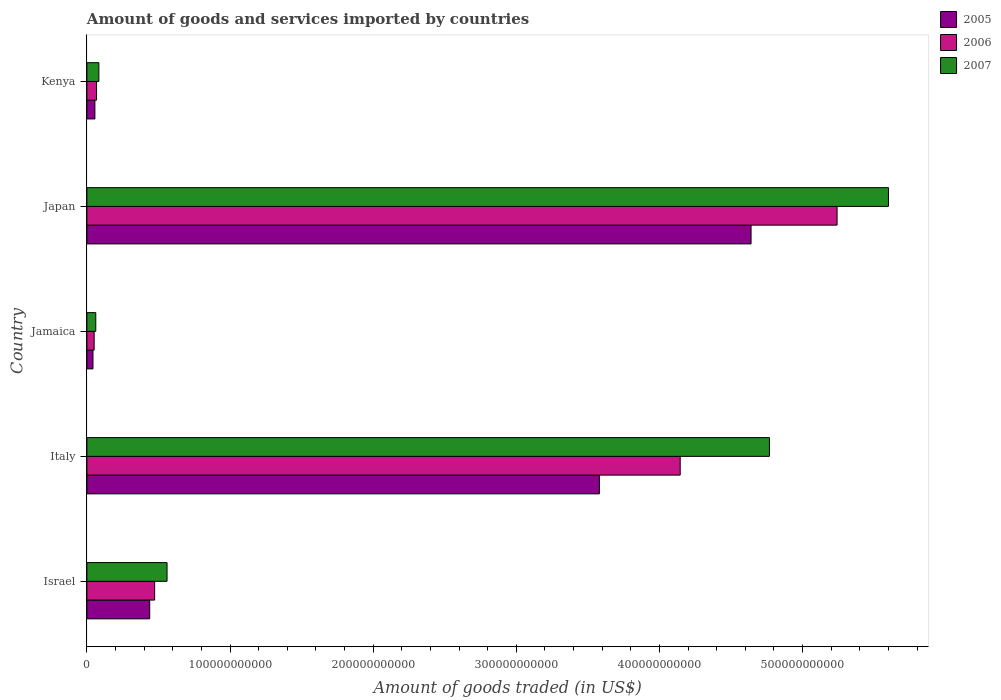How many different coloured bars are there?
Offer a terse response. 3. How many bars are there on the 1st tick from the bottom?
Offer a very short reply. 3. In how many cases, is the number of bars for a given country not equal to the number of legend labels?
Your answer should be very brief. 0. What is the total amount of goods and services imported in 2005 in Kenya?
Your answer should be very brief. 5.59e+09. Across all countries, what is the maximum total amount of goods and services imported in 2005?
Ensure brevity in your answer.  4.64e+11. Across all countries, what is the minimum total amount of goods and services imported in 2006?
Give a very brief answer. 5.08e+09. In which country was the total amount of goods and services imported in 2006 maximum?
Keep it short and to the point. Japan. In which country was the total amount of goods and services imported in 2005 minimum?
Give a very brief answer. Jamaica. What is the total total amount of goods and services imported in 2006 in the graph?
Your response must be concise. 9.98e+11. What is the difference between the total amount of goods and services imported in 2006 in Italy and that in Kenya?
Make the answer very short. 4.08e+11. What is the difference between the total amount of goods and services imported in 2007 in Japan and the total amount of goods and services imported in 2006 in Kenya?
Make the answer very short. 5.53e+11. What is the average total amount of goods and services imported in 2006 per country?
Make the answer very short. 2.00e+11. What is the difference between the total amount of goods and services imported in 2006 and total amount of goods and services imported in 2005 in Israel?
Your response must be concise. 3.46e+09. What is the ratio of the total amount of goods and services imported in 2006 in Israel to that in Italy?
Make the answer very short. 0.11. Is the difference between the total amount of goods and services imported in 2006 in Italy and Jamaica greater than the difference between the total amount of goods and services imported in 2005 in Italy and Jamaica?
Offer a terse response. Yes. What is the difference between the highest and the second highest total amount of goods and services imported in 2006?
Make the answer very short. 1.10e+11. What is the difference between the highest and the lowest total amount of goods and services imported in 2007?
Your answer should be very brief. 5.54e+11. Is the sum of the total amount of goods and services imported in 2006 in Jamaica and Japan greater than the maximum total amount of goods and services imported in 2005 across all countries?
Provide a short and direct response. Yes. What does the 1st bar from the top in Italy represents?
Make the answer very short. 2007. What does the 1st bar from the bottom in Kenya represents?
Ensure brevity in your answer.  2005. How many bars are there?
Give a very brief answer. 15. How many countries are there in the graph?
Your response must be concise. 5. What is the difference between two consecutive major ticks on the X-axis?
Give a very brief answer. 1.00e+11. Are the values on the major ticks of X-axis written in scientific E-notation?
Provide a short and direct response. No. Does the graph contain any zero values?
Offer a terse response. No. Does the graph contain grids?
Your response must be concise. No. How are the legend labels stacked?
Make the answer very short. Vertical. What is the title of the graph?
Provide a short and direct response. Amount of goods and services imported by countries. What is the label or title of the X-axis?
Ensure brevity in your answer.  Amount of goods traded (in US$). What is the Amount of goods traded (in US$) of 2005 in Israel?
Offer a very short reply. 4.39e+1. What is the Amount of goods traded (in US$) of 2006 in Israel?
Give a very brief answer. 4.73e+1. What is the Amount of goods traded (in US$) of 2007 in Israel?
Offer a very short reply. 5.60e+1. What is the Amount of goods traded (in US$) in 2005 in Italy?
Keep it short and to the point. 3.58e+11. What is the Amount of goods traded (in US$) of 2006 in Italy?
Offer a terse response. 4.15e+11. What is the Amount of goods traded (in US$) of 2007 in Italy?
Your answer should be very brief. 4.77e+11. What is the Amount of goods traded (in US$) in 2005 in Jamaica?
Your response must be concise. 4.25e+09. What is the Amount of goods traded (in US$) in 2006 in Jamaica?
Provide a succinct answer. 5.08e+09. What is the Amount of goods traded (in US$) in 2007 in Jamaica?
Give a very brief answer. 6.20e+09. What is the Amount of goods traded (in US$) of 2005 in Japan?
Keep it short and to the point. 4.64e+11. What is the Amount of goods traded (in US$) of 2006 in Japan?
Offer a very short reply. 5.24e+11. What is the Amount of goods traded (in US$) of 2007 in Japan?
Offer a very short reply. 5.60e+11. What is the Amount of goods traded (in US$) of 2005 in Kenya?
Your response must be concise. 5.59e+09. What is the Amount of goods traded (in US$) of 2006 in Kenya?
Your answer should be compact. 6.75e+09. What is the Amount of goods traded (in US$) of 2007 in Kenya?
Ensure brevity in your answer.  8.37e+09. Across all countries, what is the maximum Amount of goods traded (in US$) in 2005?
Provide a succinct answer. 4.64e+11. Across all countries, what is the maximum Amount of goods traded (in US$) in 2006?
Provide a short and direct response. 5.24e+11. Across all countries, what is the maximum Amount of goods traded (in US$) of 2007?
Your answer should be compact. 5.60e+11. Across all countries, what is the minimum Amount of goods traded (in US$) of 2005?
Offer a terse response. 4.25e+09. Across all countries, what is the minimum Amount of goods traded (in US$) in 2006?
Keep it short and to the point. 5.08e+09. Across all countries, what is the minimum Amount of goods traded (in US$) in 2007?
Your response must be concise. 6.20e+09. What is the total Amount of goods traded (in US$) in 2005 in the graph?
Give a very brief answer. 8.76e+11. What is the total Amount of goods traded (in US$) of 2006 in the graph?
Provide a succinct answer. 9.98e+11. What is the total Amount of goods traded (in US$) in 2007 in the graph?
Ensure brevity in your answer.  1.11e+12. What is the difference between the Amount of goods traded (in US$) of 2005 in Israel and that in Italy?
Provide a short and direct response. -3.14e+11. What is the difference between the Amount of goods traded (in US$) in 2006 in Israel and that in Italy?
Ensure brevity in your answer.  -3.67e+11. What is the difference between the Amount of goods traded (in US$) of 2007 in Israel and that in Italy?
Your response must be concise. -4.21e+11. What is the difference between the Amount of goods traded (in US$) of 2005 in Israel and that in Jamaica?
Give a very brief answer. 3.96e+1. What is the difference between the Amount of goods traded (in US$) in 2006 in Israel and that in Jamaica?
Make the answer very short. 4.23e+1. What is the difference between the Amount of goods traded (in US$) of 2007 in Israel and that in Jamaica?
Ensure brevity in your answer.  4.98e+1. What is the difference between the Amount of goods traded (in US$) of 2005 in Israel and that in Japan?
Provide a short and direct response. -4.20e+11. What is the difference between the Amount of goods traded (in US$) in 2006 in Israel and that in Japan?
Keep it short and to the point. -4.77e+11. What is the difference between the Amount of goods traded (in US$) in 2007 in Israel and that in Japan?
Your response must be concise. -5.04e+11. What is the difference between the Amount of goods traded (in US$) in 2005 in Israel and that in Kenya?
Your response must be concise. 3.83e+1. What is the difference between the Amount of goods traded (in US$) of 2006 in Israel and that in Kenya?
Your response must be concise. 4.06e+1. What is the difference between the Amount of goods traded (in US$) of 2007 in Israel and that in Kenya?
Ensure brevity in your answer.  4.76e+1. What is the difference between the Amount of goods traded (in US$) in 2005 in Italy and that in Jamaica?
Keep it short and to the point. 3.54e+11. What is the difference between the Amount of goods traded (in US$) of 2006 in Italy and that in Jamaica?
Offer a very short reply. 4.09e+11. What is the difference between the Amount of goods traded (in US$) in 2007 in Italy and that in Jamaica?
Provide a short and direct response. 4.71e+11. What is the difference between the Amount of goods traded (in US$) of 2005 in Italy and that in Japan?
Your answer should be compact. -1.06e+11. What is the difference between the Amount of goods traded (in US$) in 2006 in Italy and that in Japan?
Your answer should be very brief. -1.10e+11. What is the difference between the Amount of goods traded (in US$) of 2007 in Italy and that in Japan?
Make the answer very short. -8.32e+1. What is the difference between the Amount of goods traded (in US$) of 2005 in Italy and that in Kenya?
Keep it short and to the point. 3.52e+11. What is the difference between the Amount of goods traded (in US$) in 2006 in Italy and that in Kenya?
Your answer should be compact. 4.08e+11. What is the difference between the Amount of goods traded (in US$) of 2007 in Italy and that in Kenya?
Provide a succinct answer. 4.68e+11. What is the difference between the Amount of goods traded (in US$) in 2005 in Jamaica and that in Japan?
Offer a very short reply. -4.60e+11. What is the difference between the Amount of goods traded (in US$) in 2006 in Jamaica and that in Japan?
Make the answer very short. -5.19e+11. What is the difference between the Amount of goods traded (in US$) of 2007 in Jamaica and that in Japan?
Keep it short and to the point. -5.54e+11. What is the difference between the Amount of goods traded (in US$) in 2005 in Jamaica and that in Kenya?
Offer a terse response. -1.34e+09. What is the difference between the Amount of goods traded (in US$) of 2006 in Jamaica and that in Kenya?
Offer a terse response. -1.68e+09. What is the difference between the Amount of goods traded (in US$) of 2007 in Jamaica and that in Kenya?
Your response must be concise. -2.16e+09. What is the difference between the Amount of goods traded (in US$) in 2005 in Japan and that in Kenya?
Make the answer very short. 4.58e+11. What is the difference between the Amount of goods traded (in US$) in 2006 in Japan and that in Kenya?
Your answer should be compact. 5.17e+11. What is the difference between the Amount of goods traded (in US$) of 2007 in Japan and that in Kenya?
Offer a terse response. 5.52e+11. What is the difference between the Amount of goods traded (in US$) of 2005 in Israel and the Amount of goods traded (in US$) of 2006 in Italy?
Your answer should be compact. -3.71e+11. What is the difference between the Amount of goods traded (in US$) in 2005 in Israel and the Amount of goods traded (in US$) in 2007 in Italy?
Provide a succinct answer. -4.33e+11. What is the difference between the Amount of goods traded (in US$) of 2006 in Israel and the Amount of goods traded (in US$) of 2007 in Italy?
Your response must be concise. -4.30e+11. What is the difference between the Amount of goods traded (in US$) in 2005 in Israel and the Amount of goods traded (in US$) in 2006 in Jamaica?
Give a very brief answer. 3.88e+1. What is the difference between the Amount of goods traded (in US$) in 2005 in Israel and the Amount of goods traded (in US$) in 2007 in Jamaica?
Your answer should be very brief. 3.77e+1. What is the difference between the Amount of goods traded (in US$) of 2006 in Israel and the Amount of goods traded (in US$) of 2007 in Jamaica?
Your answer should be very brief. 4.11e+1. What is the difference between the Amount of goods traded (in US$) of 2005 in Israel and the Amount of goods traded (in US$) of 2006 in Japan?
Offer a very short reply. -4.80e+11. What is the difference between the Amount of goods traded (in US$) in 2005 in Israel and the Amount of goods traded (in US$) in 2007 in Japan?
Provide a short and direct response. -5.16e+11. What is the difference between the Amount of goods traded (in US$) in 2006 in Israel and the Amount of goods traded (in US$) in 2007 in Japan?
Your response must be concise. -5.13e+11. What is the difference between the Amount of goods traded (in US$) of 2005 in Israel and the Amount of goods traded (in US$) of 2006 in Kenya?
Give a very brief answer. 3.71e+1. What is the difference between the Amount of goods traded (in US$) in 2005 in Israel and the Amount of goods traded (in US$) in 2007 in Kenya?
Ensure brevity in your answer.  3.55e+1. What is the difference between the Amount of goods traded (in US$) of 2006 in Israel and the Amount of goods traded (in US$) of 2007 in Kenya?
Your answer should be compact. 3.90e+1. What is the difference between the Amount of goods traded (in US$) of 2005 in Italy and the Amount of goods traded (in US$) of 2006 in Jamaica?
Keep it short and to the point. 3.53e+11. What is the difference between the Amount of goods traded (in US$) of 2005 in Italy and the Amount of goods traded (in US$) of 2007 in Jamaica?
Your response must be concise. 3.52e+11. What is the difference between the Amount of goods traded (in US$) in 2006 in Italy and the Amount of goods traded (in US$) in 2007 in Jamaica?
Ensure brevity in your answer.  4.08e+11. What is the difference between the Amount of goods traded (in US$) of 2005 in Italy and the Amount of goods traded (in US$) of 2006 in Japan?
Your response must be concise. -1.66e+11. What is the difference between the Amount of goods traded (in US$) in 2005 in Italy and the Amount of goods traded (in US$) in 2007 in Japan?
Keep it short and to the point. -2.02e+11. What is the difference between the Amount of goods traded (in US$) in 2006 in Italy and the Amount of goods traded (in US$) in 2007 in Japan?
Provide a succinct answer. -1.46e+11. What is the difference between the Amount of goods traded (in US$) of 2005 in Italy and the Amount of goods traded (in US$) of 2006 in Kenya?
Offer a terse response. 3.51e+11. What is the difference between the Amount of goods traded (in US$) of 2005 in Italy and the Amount of goods traded (in US$) of 2007 in Kenya?
Provide a succinct answer. 3.50e+11. What is the difference between the Amount of goods traded (in US$) of 2006 in Italy and the Amount of goods traded (in US$) of 2007 in Kenya?
Provide a succinct answer. 4.06e+11. What is the difference between the Amount of goods traded (in US$) in 2005 in Jamaica and the Amount of goods traded (in US$) in 2006 in Japan?
Your answer should be compact. -5.20e+11. What is the difference between the Amount of goods traded (in US$) of 2005 in Jamaica and the Amount of goods traded (in US$) of 2007 in Japan?
Your answer should be very brief. -5.56e+11. What is the difference between the Amount of goods traded (in US$) in 2006 in Jamaica and the Amount of goods traded (in US$) in 2007 in Japan?
Provide a short and direct response. -5.55e+11. What is the difference between the Amount of goods traded (in US$) in 2005 in Jamaica and the Amount of goods traded (in US$) in 2006 in Kenya?
Make the answer very short. -2.51e+09. What is the difference between the Amount of goods traded (in US$) of 2005 in Jamaica and the Amount of goods traded (in US$) of 2007 in Kenya?
Make the answer very short. -4.12e+09. What is the difference between the Amount of goods traded (in US$) of 2006 in Jamaica and the Amount of goods traded (in US$) of 2007 in Kenya?
Provide a short and direct response. -3.29e+09. What is the difference between the Amount of goods traded (in US$) of 2005 in Japan and the Amount of goods traded (in US$) of 2006 in Kenya?
Your response must be concise. 4.57e+11. What is the difference between the Amount of goods traded (in US$) of 2005 in Japan and the Amount of goods traded (in US$) of 2007 in Kenya?
Provide a short and direct response. 4.56e+11. What is the difference between the Amount of goods traded (in US$) in 2006 in Japan and the Amount of goods traded (in US$) in 2007 in Kenya?
Your answer should be very brief. 5.16e+11. What is the average Amount of goods traded (in US$) of 2005 per country?
Provide a short and direct response. 1.75e+11. What is the average Amount of goods traded (in US$) of 2006 per country?
Give a very brief answer. 2.00e+11. What is the average Amount of goods traded (in US$) in 2007 per country?
Make the answer very short. 2.21e+11. What is the difference between the Amount of goods traded (in US$) in 2005 and Amount of goods traded (in US$) in 2006 in Israel?
Your response must be concise. -3.46e+09. What is the difference between the Amount of goods traded (in US$) in 2005 and Amount of goods traded (in US$) in 2007 in Israel?
Give a very brief answer. -1.21e+1. What is the difference between the Amount of goods traded (in US$) in 2006 and Amount of goods traded (in US$) in 2007 in Israel?
Keep it short and to the point. -8.65e+09. What is the difference between the Amount of goods traded (in US$) in 2005 and Amount of goods traded (in US$) in 2006 in Italy?
Ensure brevity in your answer.  -5.65e+1. What is the difference between the Amount of goods traded (in US$) of 2005 and Amount of goods traded (in US$) of 2007 in Italy?
Make the answer very short. -1.19e+11. What is the difference between the Amount of goods traded (in US$) in 2006 and Amount of goods traded (in US$) in 2007 in Italy?
Give a very brief answer. -6.23e+1. What is the difference between the Amount of goods traded (in US$) of 2005 and Amount of goods traded (in US$) of 2006 in Jamaica?
Your answer should be very brief. -8.32e+08. What is the difference between the Amount of goods traded (in US$) in 2005 and Amount of goods traded (in US$) in 2007 in Jamaica?
Your answer should be compact. -1.96e+09. What is the difference between the Amount of goods traded (in US$) of 2006 and Amount of goods traded (in US$) of 2007 in Jamaica?
Your answer should be compact. -1.13e+09. What is the difference between the Amount of goods traded (in US$) in 2005 and Amount of goods traded (in US$) in 2006 in Japan?
Offer a terse response. -6.01e+1. What is the difference between the Amount of goods traded (in US$) in 2005 and Amount of goods traded (in US$) in 2007 in Japan?
Provide a succinct answer. -9.60e+1. What is the difference between the Amount of goods traded (in US$) of 2006 and Amount of goods traded (in US$) of 2007 in Japan?
Your answer should be compact. -3.59e+1. What is the difference between the Amount of goods traded (in US$) of 2005 and Amount of goods traded (in US$) of 2006 in Kenya?
Provide a short and direct response. -1.17e+09. What is the difference between the Amount of goods traded (in US$) of 2005 and Amount of goods traded (in US$) of 2007 in Kenya?
Offer a terse response. -2.78e+09. What is the difference between the Amount of goods traded (in US$) in 2006 and Amount of goods traded (in US$) in 2007 in Kenya?
Provide a short and direct response. -1.62e+09. What is the ratio of the Amount of goods traded (in US$) in 2005 in Israel to that in Italy?
Your answer should be compact. 0.12. What is the ratio of the Amount of goods traded (in US$) in 2006 in Israel to that in Italy?
Your response must be concise. 0.11. What is the ratio of the Amount of goods traded (in US$) of 2007 in Israel to that in Italy?
Offer a very short reply. 0.12. What is the ratio of the Amount of goods traded (in US$) in 2005 in Israel to that in Jamaica?
Your answer should be very brief. 10.34. What is the ratio of the Amount of goods traded (in US$) of 2006 in Israel to that in Jamaica?
Ensure brevity in your answer.  9.33. What is the ratio of the Amount of goods traded (in US$) of 2007 in Israel to that in Jamaica?
Offer a terse response. 9.03. What is the ratio of the Amount of goods traded (in US$) of 2005 in Israel to that in Japan?
Your answer should be compact. 0.09. What is the ratio of the Amount of goods traded (in US$) in 2006 in Israel to that in Japan?
Ensure brevity in your answer.  0.09. What is the ratio of the Amount of goods traded (in US$) in 2007 in Israel to that in Japan?
Ensure brevity in your answer.  0.1. What is the ratio of the Amount of goods traded (in US$) of 2005 in Israel to that in Kenya?
Keep it short and to the point. 7.86. What is the ratio of the Amount of goods traded (in US$) of 2006 in Israel to that in Kenya?
Your answer should be very brief. 7.01. What is the ratio of the Amount of goods traded (in US$) in 2007 in Israel to that in Kenya?
Your answer should be very brief. 6.69. What is the ratio of the Amount of goods traded (in US$) of 2005 in Italy to that in Jamaica?
Your answer should be compact. 84.34. What is the ratio of the Amount of goods traded (in US$) in 2006 in Italy to that in Jamaica?
Give a very brief answer. 81.64. What is the ratio of the Amount of goods traded (in US$) in 2007 in Italy to that in Jamaica?
Give a very brief answer. 76.86. What is the ratio of the Amount of goods traded (in US$) of 2005 in Italy to that in Japan?
Provide a succinct answer. 0.77. What is the ratio of the Amount of goods traded (in US$) of 2006 in Italy to that in Japan?
Provide a short and direct response. 0.79. What is the ratio of the Amount of goods traded (in US$) of 2007 in Italy to that in Japan?
Give a very brief answer. 0.85. What is the ratio of the Amount of goods traded (in US$) in 2005 in Italy to that in Kenya?
Provide a succinct answer. 64.09. What is the ratio of the Amount of goods traded (in US$) in 2006 in Italy to that in Kenya?
Provide a succinct answer. 61.39. What is the ratio of the Amount of goods traded (in US$) of 2007 in Italy to that in Kenya?
Keep it short and to the point. 56.98. What is the ratio of the Amount of goods traded (in US$) in 2005 in Jamaica to that in Japan?
Make the answer very short. 0.01. What is the ratio of the Amount of goods traded (in US$) of 2006 in Jamaica to that in Japan?
Ensure brevity in your answer.  0.01. What is the ratio of the Amount of goods traded (in US$) of 2007 in Jamaica to that in Japan?
Provide a short and direct response. 0.01. What is the ratio of the Amount of goods traded (in US$) in 2005 in Jamaica to that in Kenya?
Your answer should be compact. 0.76. What is the ratio of the Amount of goods traded (in US$) of 2006 in Jamaica to that in Kenya?
Give a very brief answer. 0.75. What is the ratio of the Amount of goods traded (in US$) of 2007 in Jamaica to that in Kenya?
Provide a succinct answer. 0.74. What is the ratio of the Amount of goods traded (in US$) of 2005 in Japan to that in Kenya?
Your answer should be compact. 83.06. What is the ratio of the Amount of goods traded (in US$) in 2006 in Japan to that in Kenya?
Keep it short and to the point. 77.62. What is the ratio of the Amount of goods traded (in US$) in 2007 in Japan to that in Kenya?
Make the answer very short. 66.92. What is the difference between the highest and the second highest Amount of goods traded (in US$) in 2005?
Provide a short and direct response. 1.06e+11. What is the difference between the highest and the second highest Amount of goods traded (in US$) in 2006?
Offer a terse response. 1.10e+11. What is the difference between the highest and the second highest Amount of goods traded (in US$) in 2007?
Your answer should be compact. 8.32e+1. What is the difference between the highest and the lowest Amount of goods traded (in US$) of 2005?
Keep it short and to the point. 4.60e+11. What is the difference between the highest and the lowest Amount of goods traded (in US$) of 2006?
Give a very brief answer. 5.19e+11. What is the difference between the highest and the lowest Amount of goods traded (in US$) of 2007?
Keep it short and to the point. 5.54e+11. 